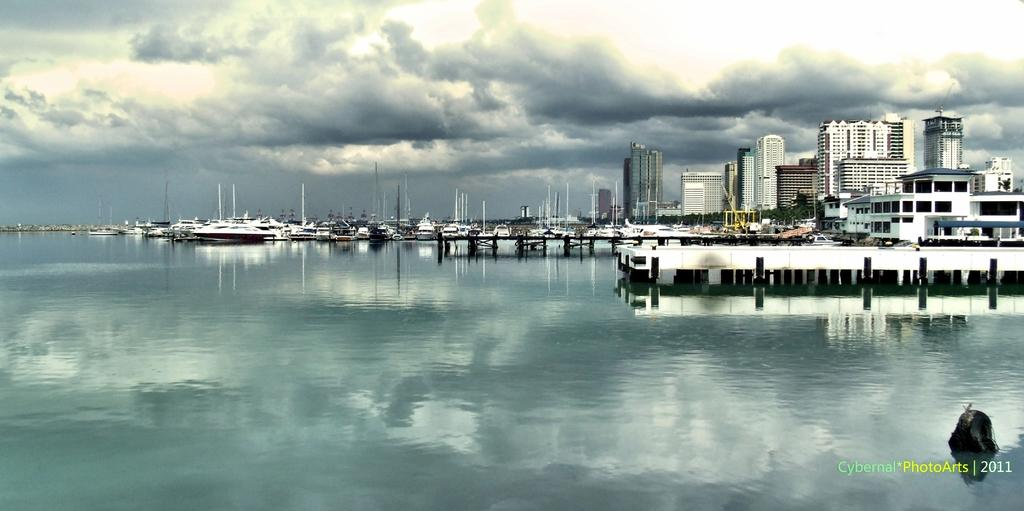What is located in the water in the image? There are ships in the water in the image. What can be seen in the background of the image? There are buildings, trees, and the sky visible in the background of the image. Where is the text located in the image? The text is on the right side of the image. Can you see a deer wearing a mitten on the left side of the image? There is no deer or mitten present on the left side of the image. How many pages are visible in the image? There are no pages present in the image. 